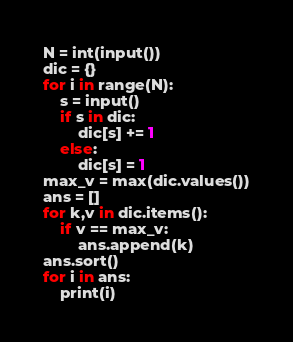Convert code to text. <code><loc_0><loc_0><loc_500><loc_500><_Python_>N = int(input())
dic = {}
for i in range(N):
    s = input()
    if s in dic:
        dic[s] += 1
    else:
        dic[s] = 1
max_v = max(dic.values())
ans = []
for k,v in dic.items():
    if v == max_v:
        ans.append(k)
ans.sort()
for i in ans:
    print(i)</code> 